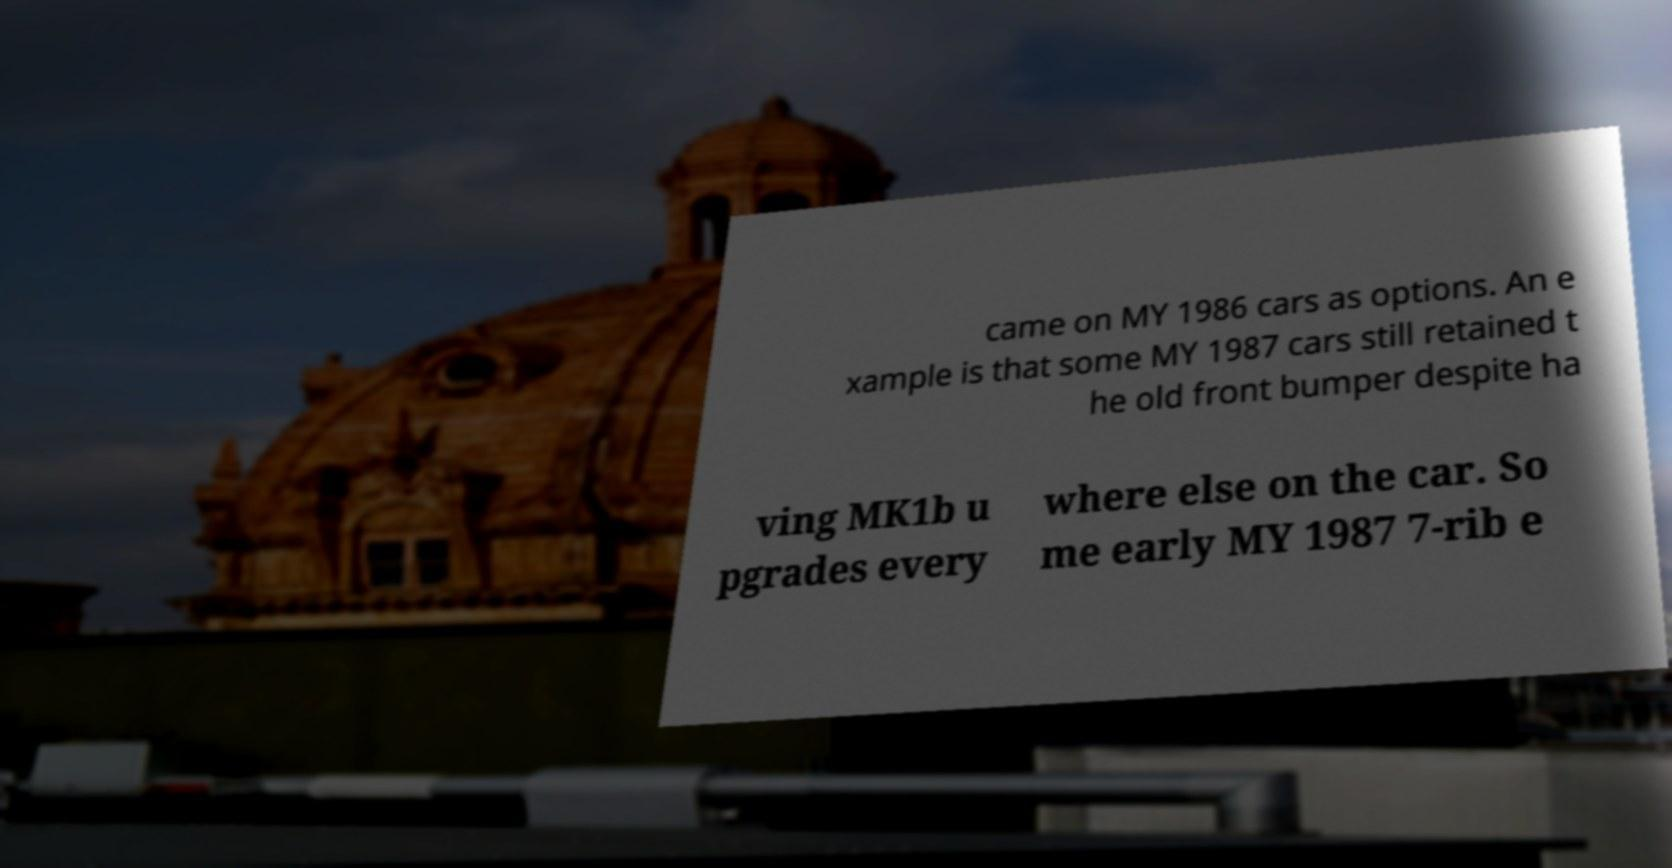For documentation purposes, I need the text within this image transcribed. Could you provide that? came on MY 1986 cars as options. An e xample is that some MY 1987 cars still retained t he old front bumper despite ha ving MK1b u pgrades every where else on the car. So me early MY 1987 7-rib e 